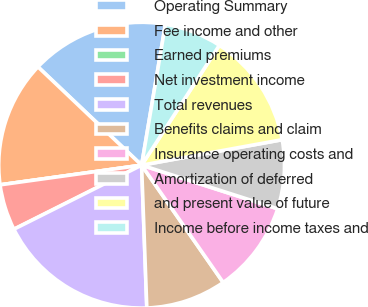Convert chart to OTSL. <chart><loc_0><loc_0><loc_500><loc_500><pie_chart><fcel>Operating Summary<fcel>Fee income and other<fcel>Earned premiums<fcel>Net investment income<fcel>Total revenues<fcel>Benefits claims and claim<fcel>Insurance operating costs and<fcel>Amortization of deferred<fcel>and present value of future<fcel>Income before income taxes and<nl><fcel>15.58%<fcel>14.28%<fcel>0.0%<fcel>5.2%<fcel>18.18%<fcel>9.09%<fcel>10.39%<fcel>7.79%<fcel>12.99%<fcel>6.49%<nl></chart> 